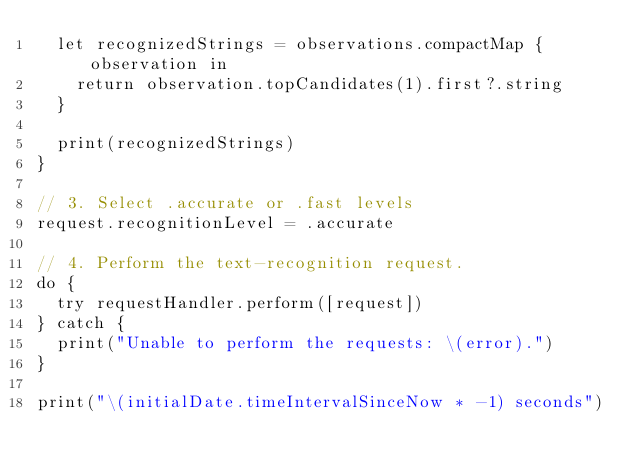<code> <loc_0><loc_0><loc_500><loc_500><_Swift_>  let recognizedStrings = observations.compactMap { observation in
    return observation.topCandidates(1).first?.string
  }

  print(recognizedStrings)
}

// 3. Select .accurate or .fast levels
request.recognitionLevel = .accurate

// 4. Perform the text-recognition request.
do {
  try requestHandler.perform([request])
} catch {
  print("Unable to perform the requests: \(error).")
}

print("\(initialDate.timeIntervalSinceNow * -1) seconds")
</code> 